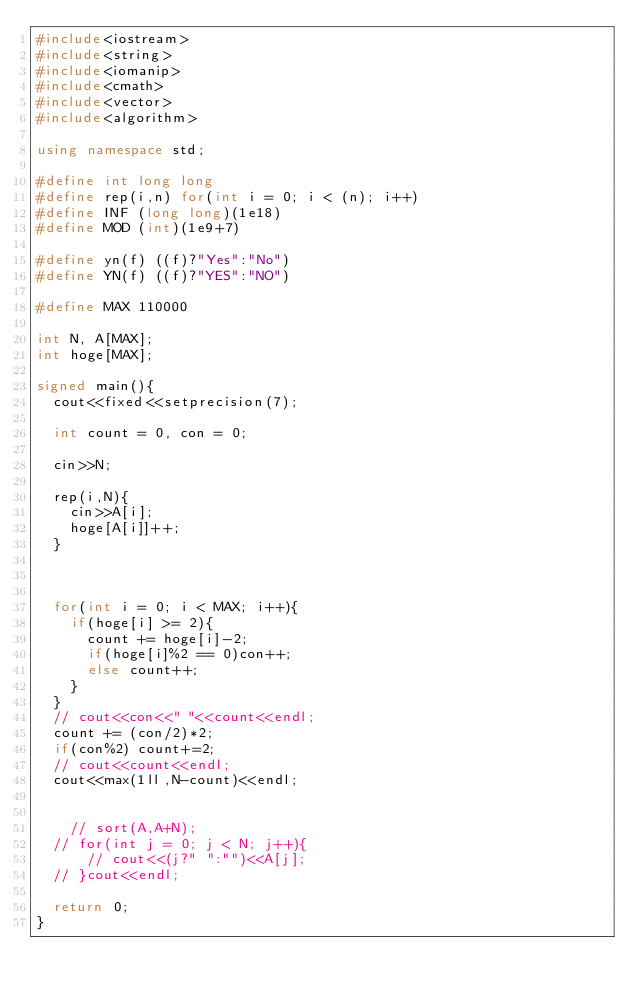Convert code to text. <code><loc_0><loc_0><loc_500><loc_500><_C++_>#include<iostream>
#include<string>
#include<iomanip>
#include<cmath>
#include<vector>
#include<algorithm>

using namespace std;

#define int long long
#define rep(i,n) for(int i = 0; i < (n); i++)
#define INF (long long)(1e18)
#define MOD (int)(1e9+7)

#define yn(f) ((f)?"Yes":"No")
#define YN(f) ((f)?"YES":"NO")

#define MAX 110000

int N, A[MAX];
int hoge[MAX];

signed main(){
	cout<<fixed<<setprecision(7);
	
	int count = 0, con = 0;
	
	cin>>N;
	
	rep(i,N){
		cin>>A[i];
		hoge[A[i]]++;
	}
	

	
	for(int i = 0; i < MAX; i++){
		if(hoge[i] >= 2){
			count += hoge[i]-2;
			if(hoge[i]%2 == 0)con++;
			else count++;
		}
	}
	// cout<<con<<" "<<count<<endl;
	count += (con/2)*2;
	if(con%2) count+=2;
	// cout<<count<<endl;
	cout<<max(1ll,N-count)<<endl;
	
	
		// sort(A,A+N);
	// for(int j = 0; j < N; j++){
			// cout<<(j?" ":"")<<A[j];
	// }cout<<endl;
	
	return 0;
}</code> 